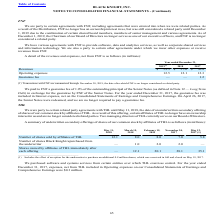According to Black Knight Financial Services's financial document, What does the company's agreements with FNF entail the provision of? software, data and analytics services, as well as corporate shared services and information technology.. The document states: "We have various agreements with FNF to provide software, data and analytics services, as well as corporate shared services and information technology...." Also, What was the revenue in 2019? According to the financial document, 59.5 (in millions). The relevant text states: "Revenues $ 59.5 $ 57.6 $ 56.8..." Also, What were the operating expenses in 2017? According to the financial document, 12.3 (in millions). The relevant text states: "Operating expenses 12.5 12.1 12.3..." Additionally, Which years did Revenues exceed $55 million? The document contains multiple relevant values: 2019, 2018, 2017. From the document: "2019 (1) 2018 2017 2019 (1) 2018 2017 2019 (1) 2018 2017..." Also, can you calculate: What was the change in operating expenses between 2017 and 2018? Based on the calculation: 12.1-12.3, the result is -0.2 (in millions). This is based on the information: "Operating expenses 12.5 12.1 12.3 Operating expenses 12.5 12.1 12.3..." The key data points involved are: 12.1, 12.3. Also, can you calculate: What was the percentage change in operating expenses between 2018 and 2019? To answer this question, I need to perform calculations using the financial data. The calculation is: (12.5-12.1)/12.1, which equals 3.31 (percentage). This is based on the information: "Operating expenses 12.5 12.1 12.3 Operating expenses 12.5 12.1 12.3..." The key data points involved are: 12.1, 12.5. 